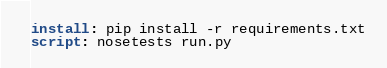Convert code to text. <code><loc_0><loc_0><loc_500><loc_500><_YAML_>install: pip install -r requirements.txt
script: nosetests run.py
</code> 